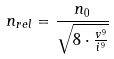Convert formula to latex. <formula><loc_0><loc_0><loc_500><loc_500>n _ { r e l } = \frac { n _ { 0 } } { \sqrt { 8 \cdot \frac { v ^ { 9 } } { i ^ { 9 } } } }</formula> 